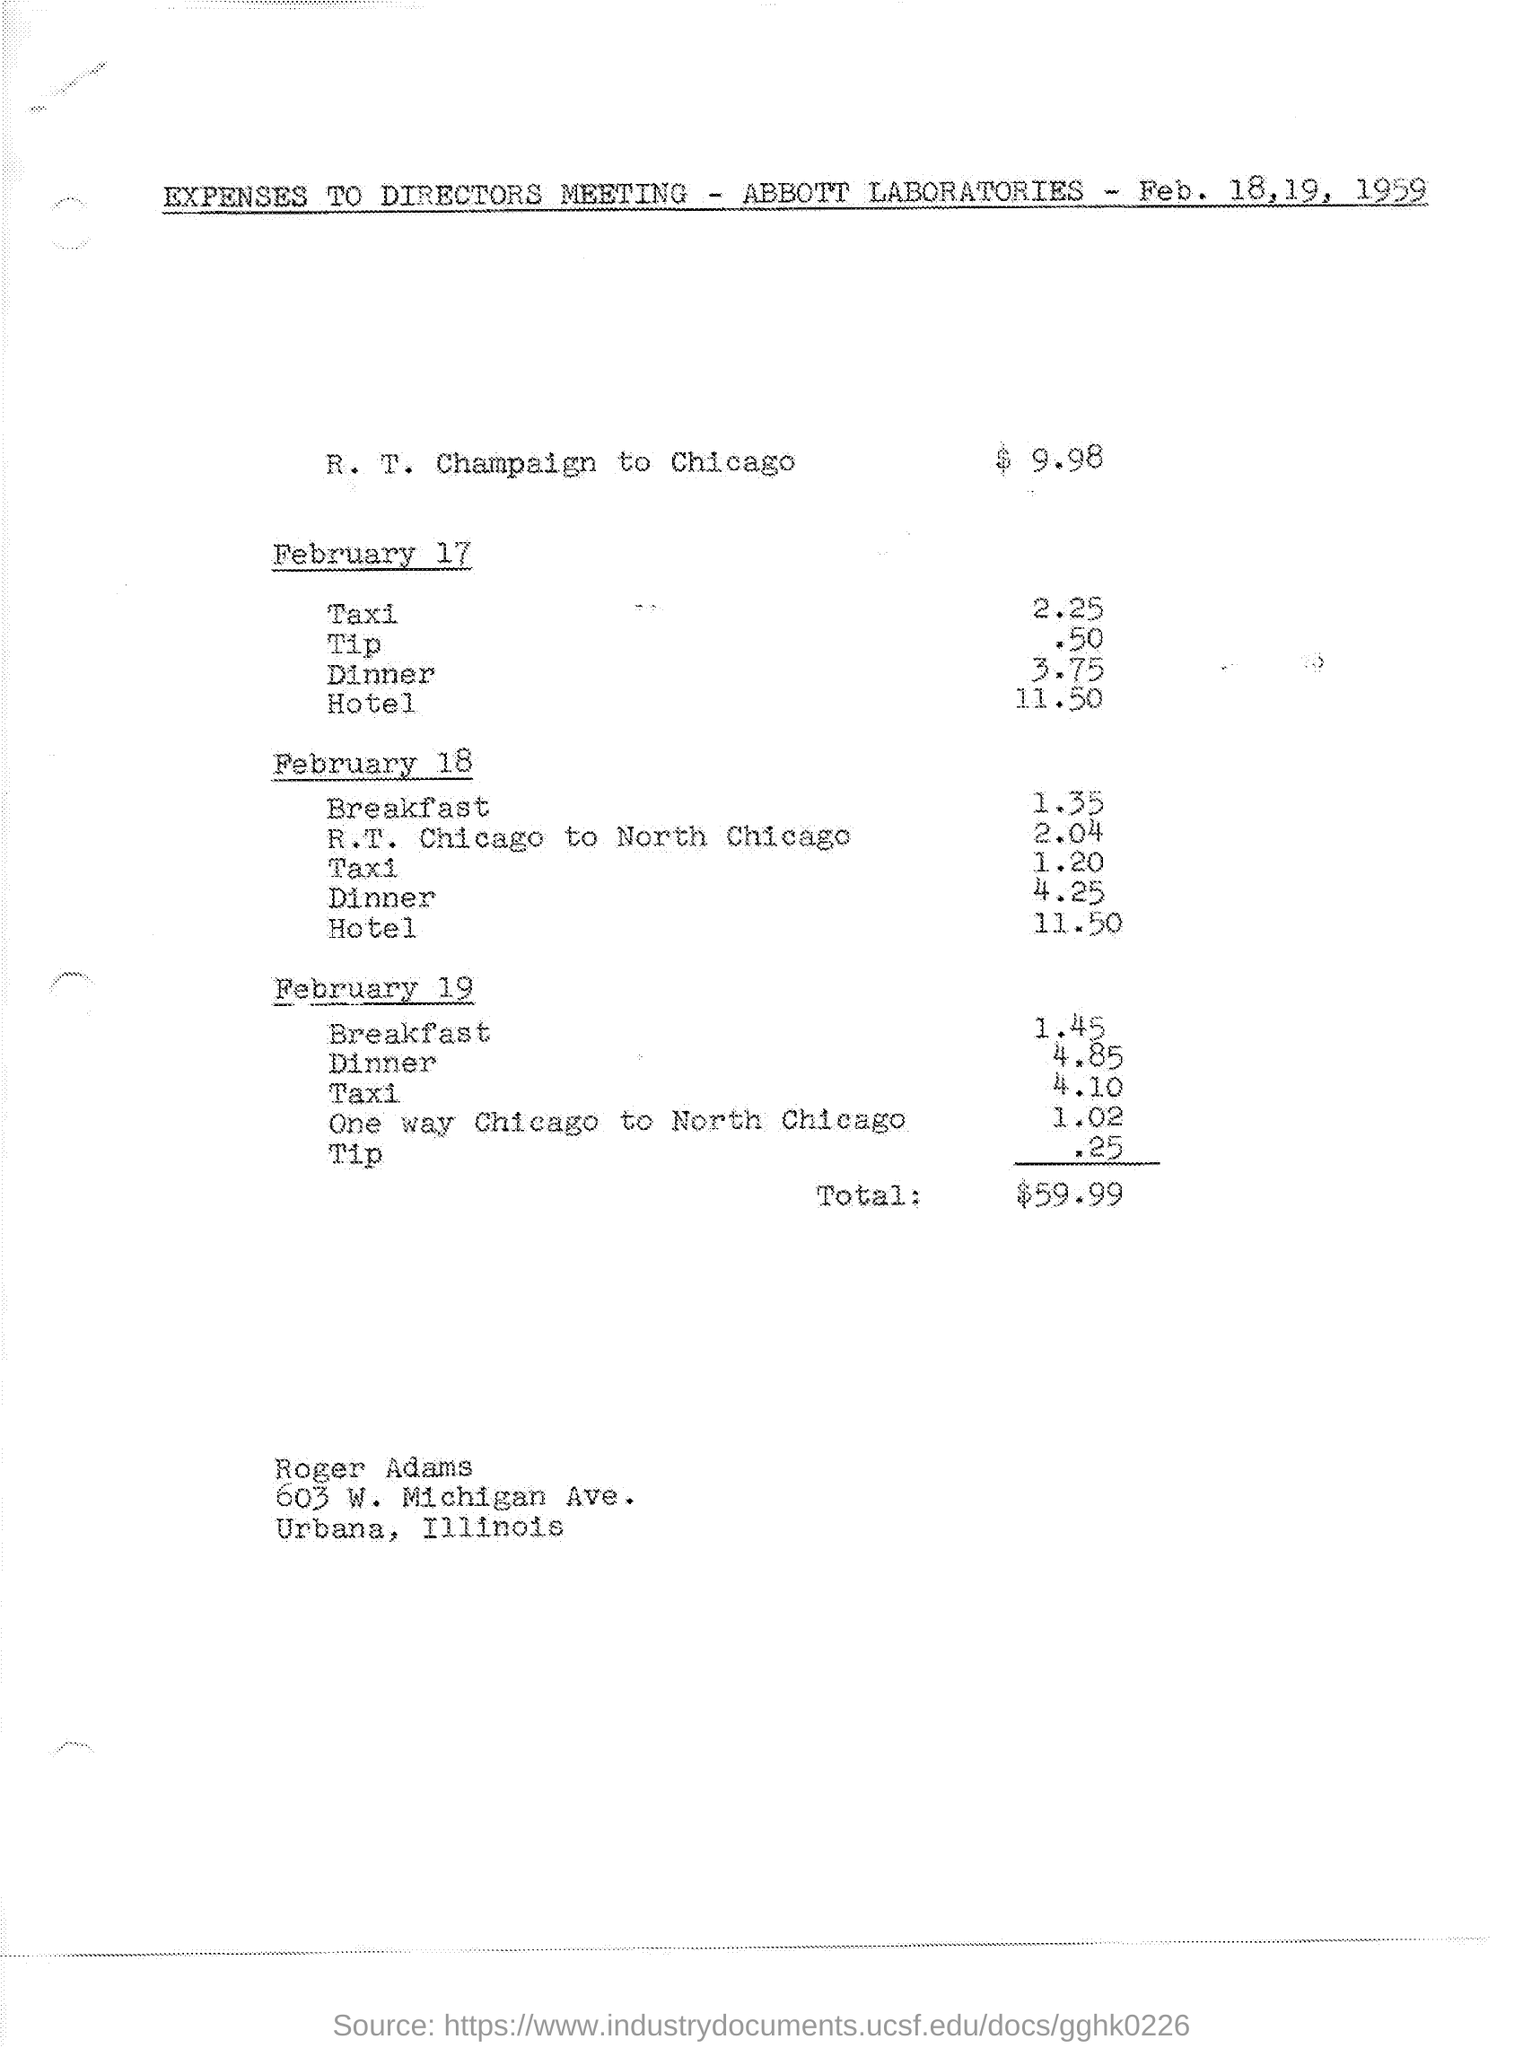Point out several critical features in this image. On February 18, the cost of a hotel was 11.50. The expenses for breakfast on February 18 amounted to 1.35. On February 18th, the expenses for dinner were 4 and 25. On February 17th, the expenses for taxi were 2.25. The cost for traveling from Chicago to North Chicago on February 19th is $1.02. 